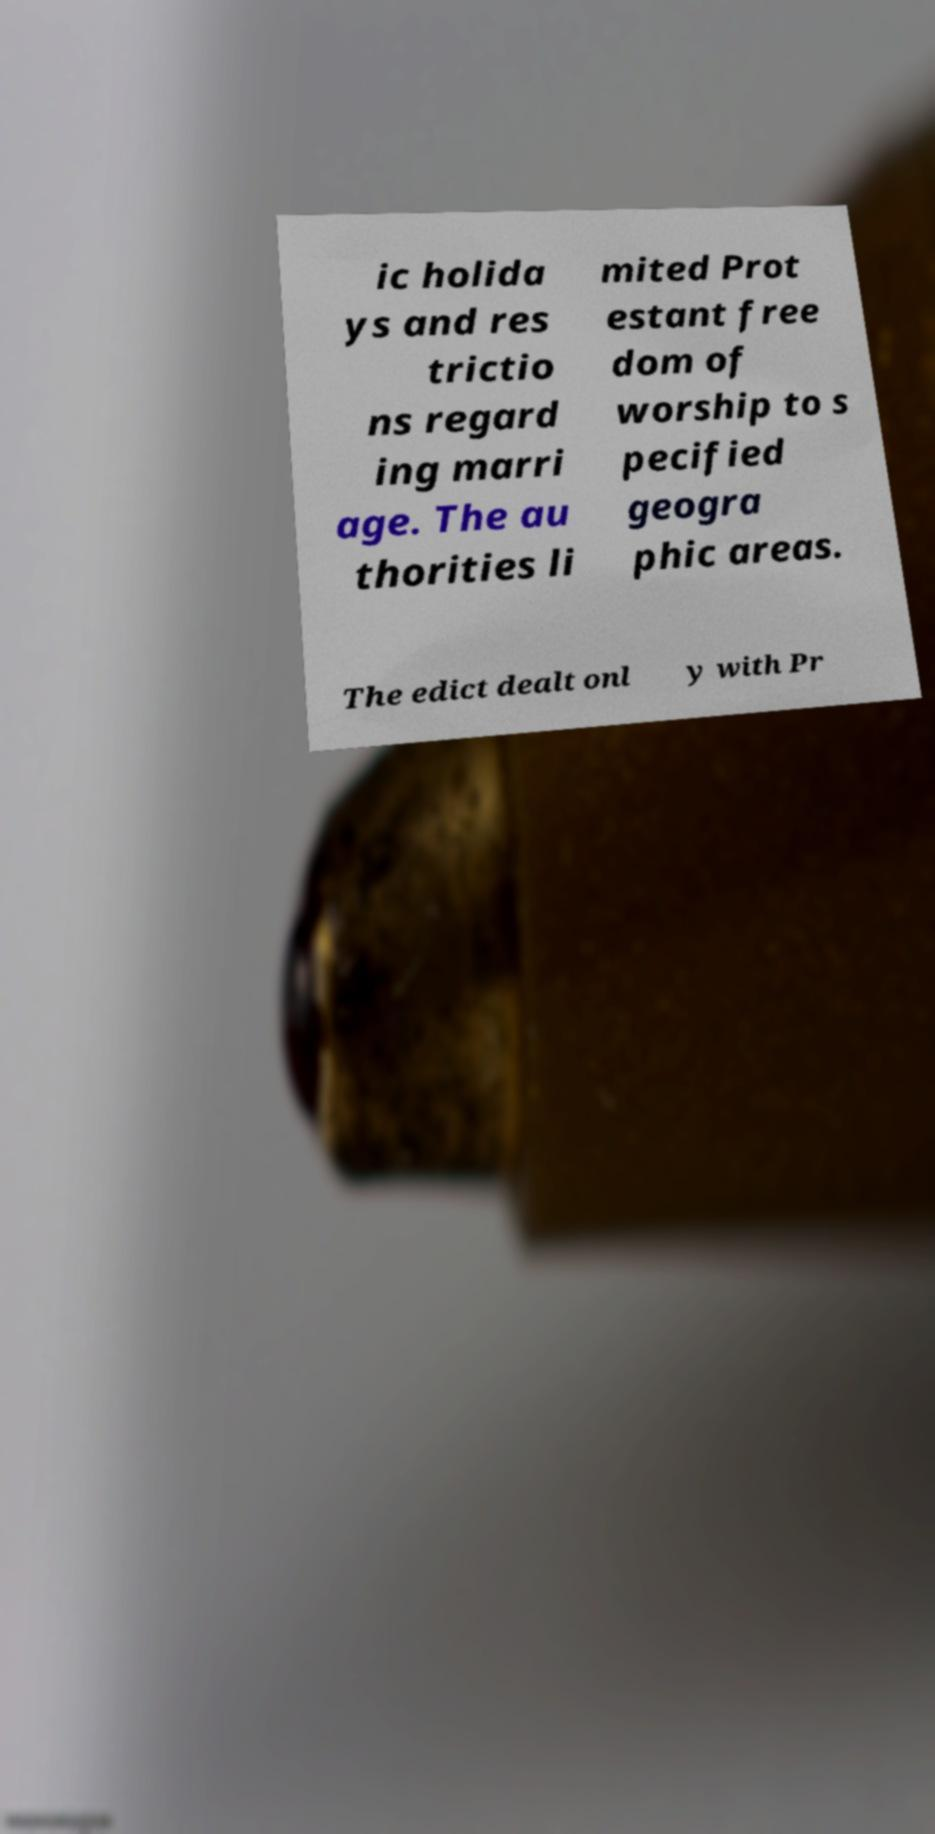Can you accurately transcribe the text from the provided image for me? ic holida ys and res trictio ns regard ing marri age. The au thorities li mited Prot estant free dom of worship to s pecified geogra phic areas. The edict dealt onl y with Pr 